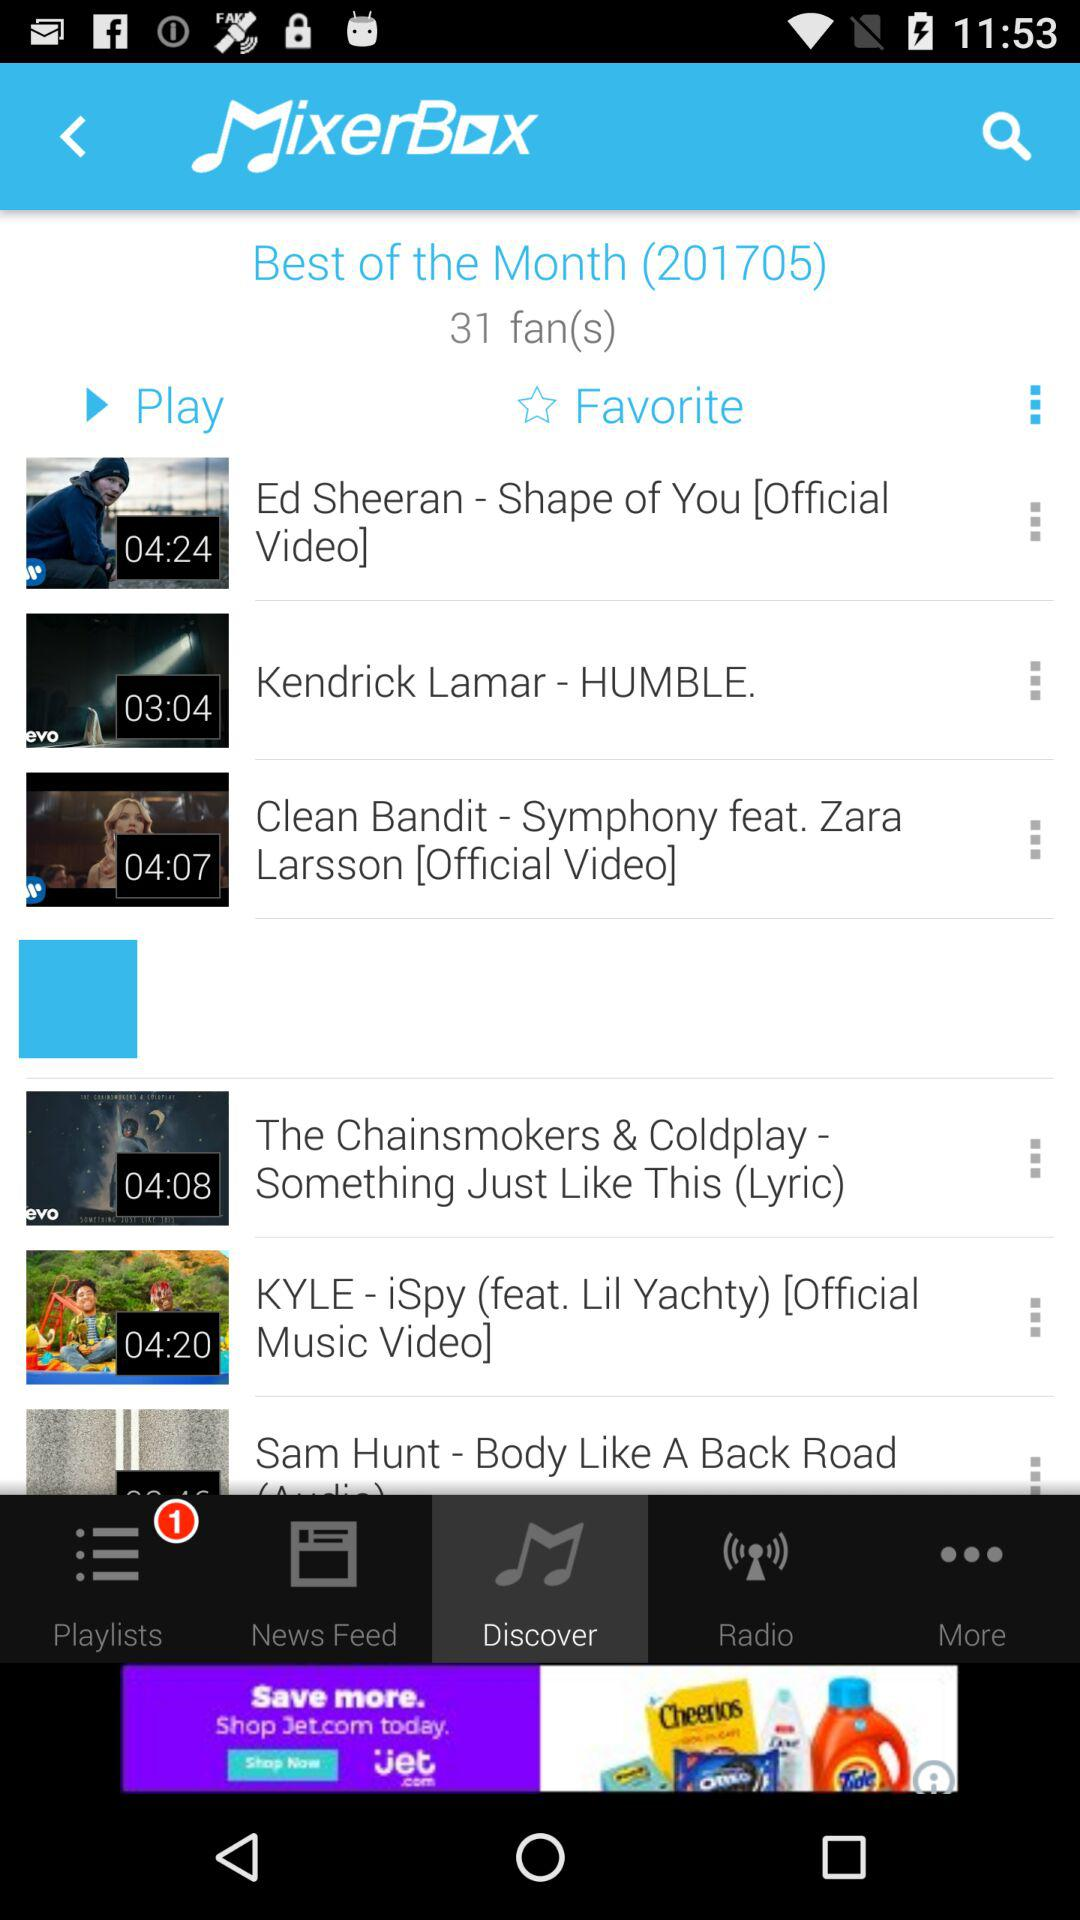What is the application name? The application name is "Mixerbox". 